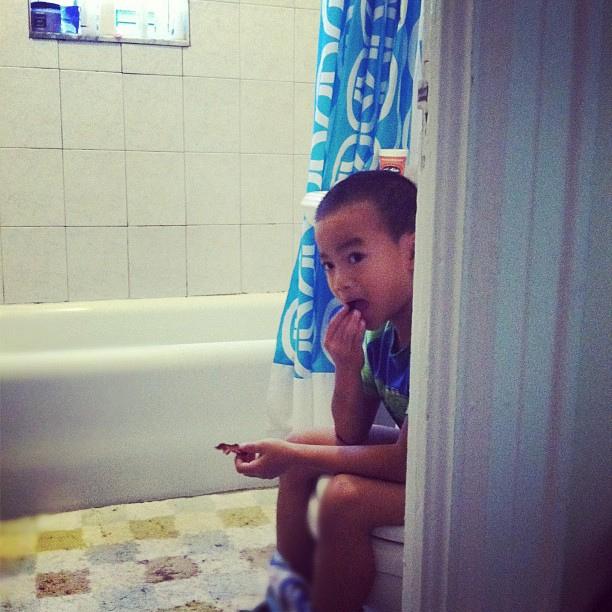What is the boy doing?
Short answer required. Using toilet. What color shirt is this person wearing?
Short answer required. Blue. Does the floor look clean?
Answer briefly. No. What color is the tile on the wall?
Give a very brief answer. White. What is the boy sitting on?
Write a very short answer. Toilet. 